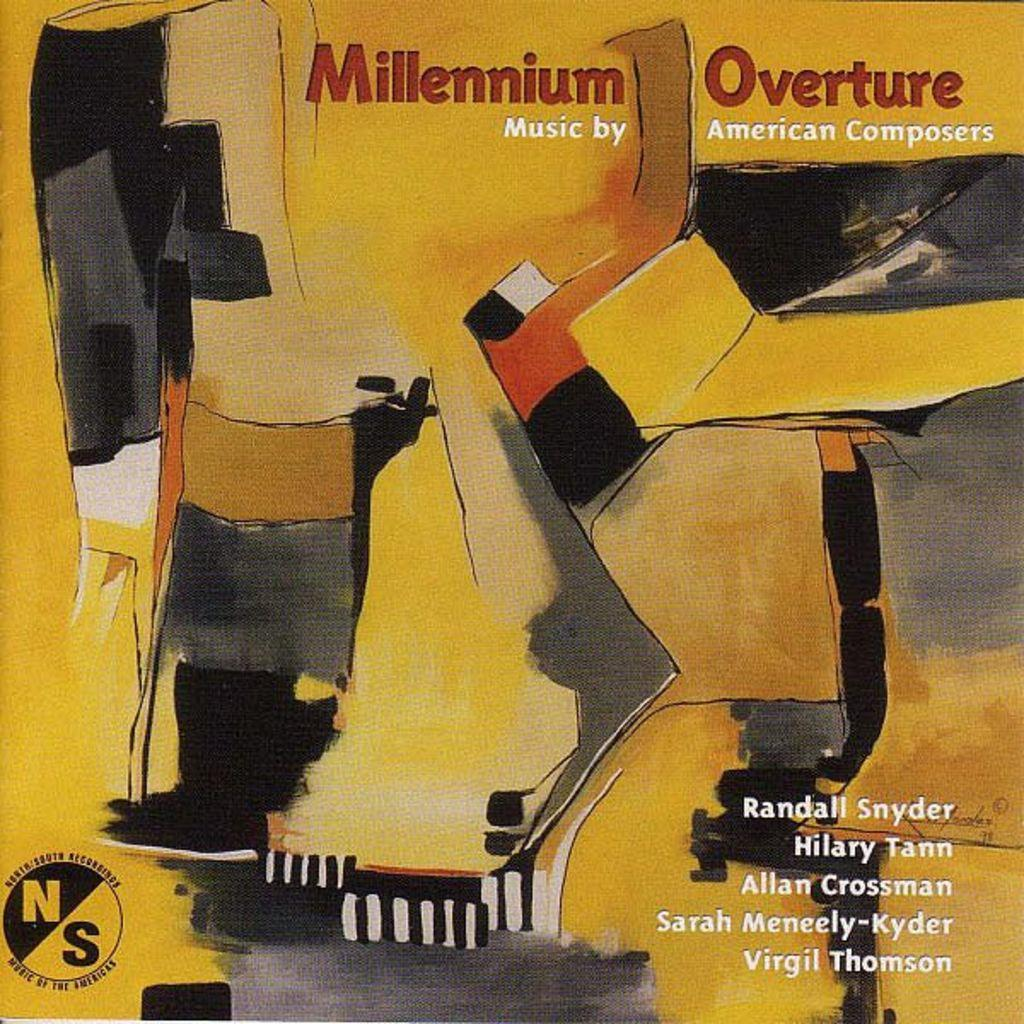What type of visual art is present in the image? There is a poster and a painting in the image. Where can you find text in the image? There is text in the right bottom, left bottom, and top of the image. What is located in the left bottom of the image? There is a logo in the left bottom of the image. What is located in the right bottom of the image? There is text in the right bottom of the image. Can you hear the clock ticking in the image? There is no clock present in the image, so it is not possible to hear it ticking. 